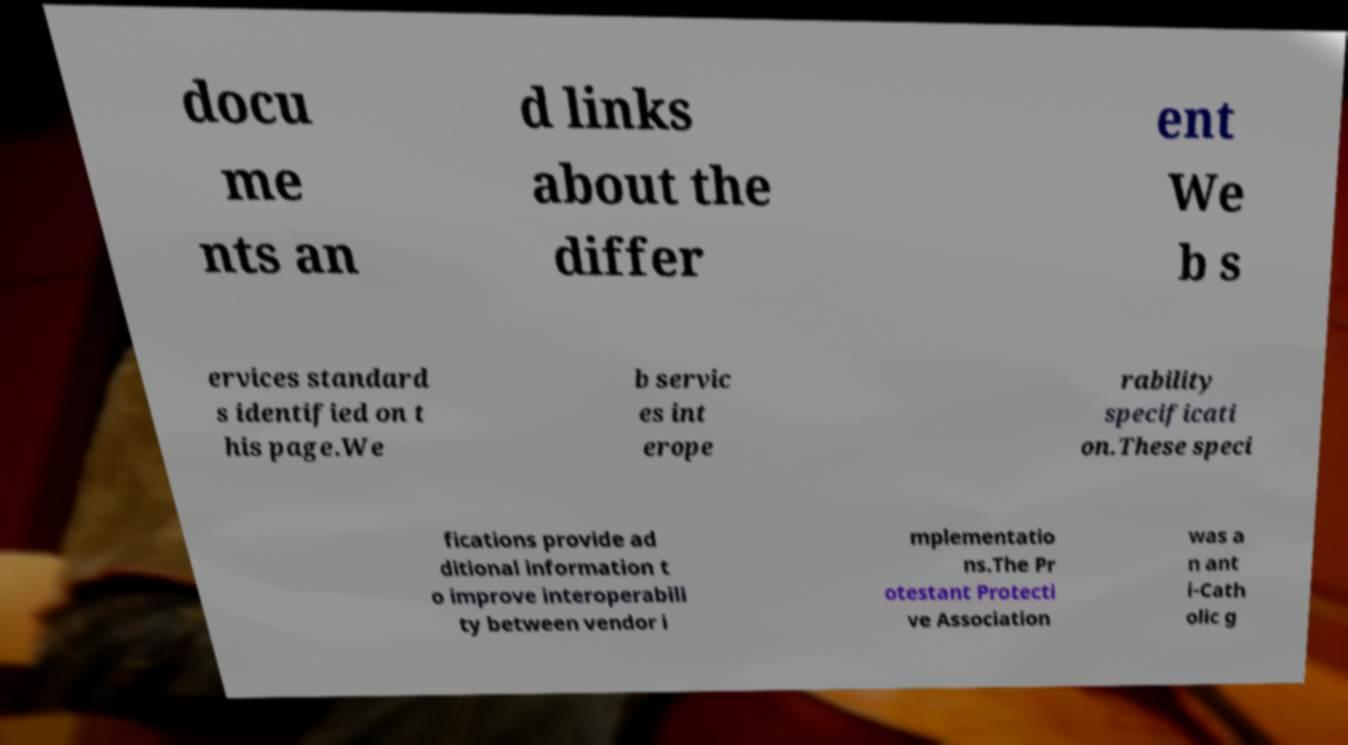What messages or text are displayed in this image? I need them in a readable, typed format. docu me nts an d links about the differ ent We b s ervices standard s identified on t his page.We b servic es int erope rability specificati on.These speci fications provide ad ditional information t o improve interoperabili ty between vendor i mplementatio ns.The Pr otestant Protecti ve Association was a n ant i-Cath olic g 